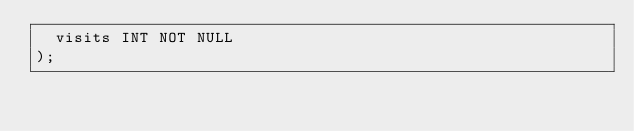<code> <loc_0><loc_0><loc_500><loc_500><_SQL_>  visits INT NOT NULL
);</code> 